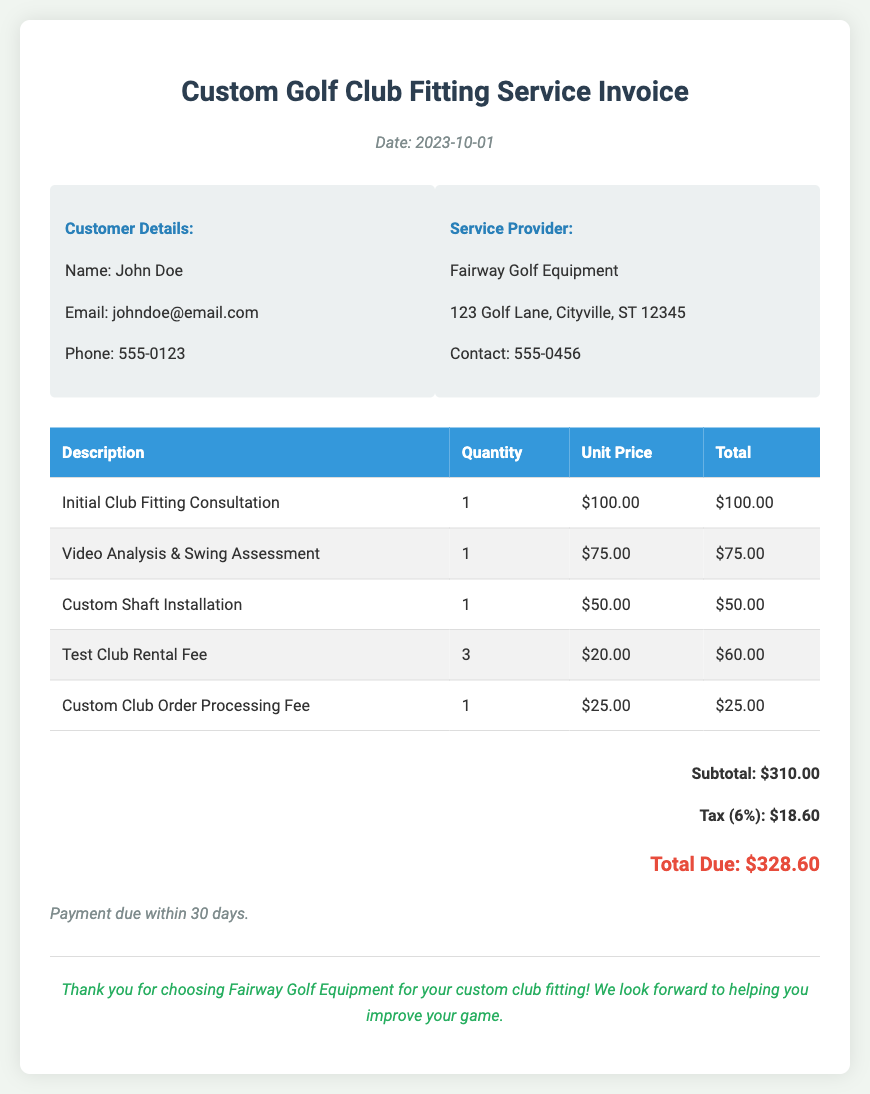What is the date of the invoice? The date of the invoice is displayed prominently in the document header.
Answer: 2023-10-01 Who is the customer? The customer's name is listed under customer details.
Answer: John Doe What is the subtotal of the invoice? The subtotal is provided in the total section of the invoice.
Answer: $310.00 What is the tax percentage applied? The tax percentage is mentioned in the total section of the invoice as part of the calculation.
Answer: 6% How many test clubs were rented? The quantity of test club rental fee is specified in the itemized charges table.
Answer: 3 What is the total due? The total amount due is stated clearly at the bottom of the invoice.
Answer: $328.60 What service is being charged $75.00? The description of the charge can be found in the itemized services table.
Answer: Video Analysis & Swing Assessment What is the name of the service provider? The service provider's name is listed in the service provider details section.
Answer: Fairway Golf Equipment What is the payment due time frame? The document specifies payment terms that indicate when payment is due.
Answer: 30 days 